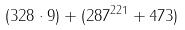Convert formula to latex. <formula><loc_0><loc_0><loc_500><loc_500>( 3 2 8 \cdot 9 ) + ( 2 8 7 ^ { 2 2 1 } + 4 7 3 )</formula> 